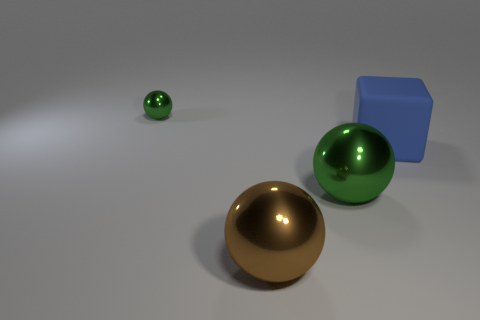How many big green metallic things are the same shape as the small metallic thing?
Your answer should be compact. 1. There is a metallic thing that is behind the green shiny sphere that is in front of the big matte thing; what color is it?
Offer a very short reply. Green. Is the number of big blue things that are behind the large rubber block the same as the number of tiny red things?
Give a very brief answer. Yes. Is there another brown object of the same size as the brown metal object?
Your answer should be very brief. No. Do the cube and the metallic object that is behind the large green metal ball have the same size?
Offer a very short reply. No. Are there the same number of tiny balls right of the tiny green metallic object and large rubber blocks that are on the left side of the brown metal object?
Offer a terse response. Yes. The large metallic object that is the same color as the tiny object is what shape?
Your answer should be compact. Sphere. What is the green sphere on the left side of the brown metal ball made of?
Your answer should be compact. Metal. Does the blue object have the same size as the brown object?
Keep it short and to the point. Yes. Are there more large brown spheres right of the big green metallic thing than big spheres?
Ensure brevity in your answer.  No. 